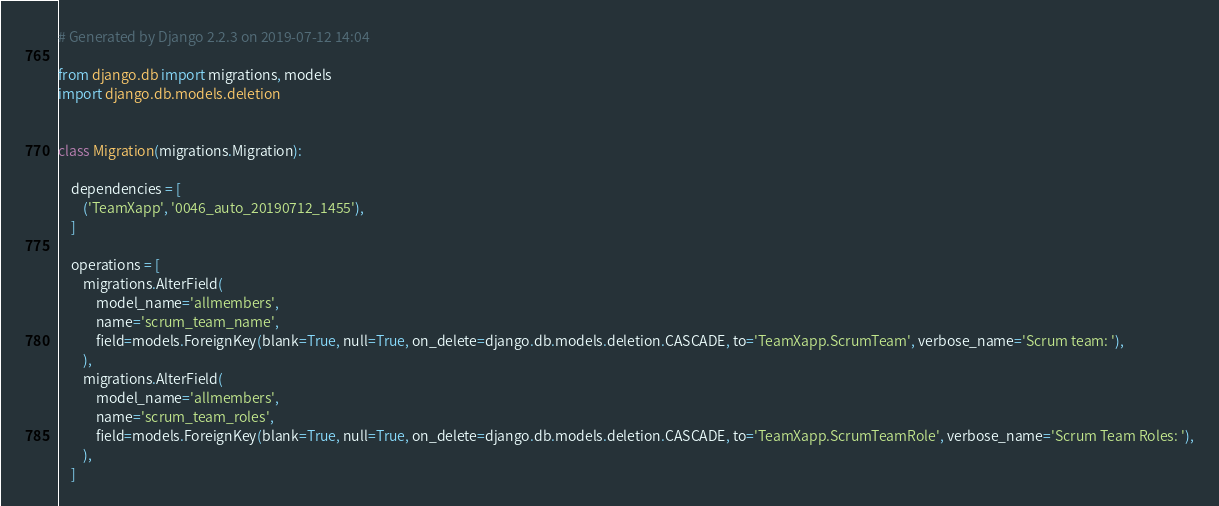<code> <loc_0><loc_0><loc_500><loc_500><_Python_># Generated by Django 2.2.3 on 2019-07-12 14:04

from django.db import migrations, models
import django.db.models.deletion


class Migration(migrations.Migration):

    dependencies = [
        ('TeamXapp', '0046_auto_20190712_1455'),
    ]

    operations = [
        migrations.AlterField(
            model_name='allmembers',
            name='scrum_team_name',
            field=models.ForeignKey(blank=True, null=True, on_delete=django.db.models.deletion.CASCADE, to='TeamXapp.ScrumTeam', verbose_name='Scrum team: '),
        ),
        migrations.AlterField(
            model_name='allmembers',
            name='scrum_team_roles',
            field=models.ForeignKey(blank=True, null=True, on_delete=django.db.models.deletion.CASCADE, to='TeamXapp.ScrumTeamRole', verbose_name='Scrum Team Roles: '),
        ),
    ]
</code> 